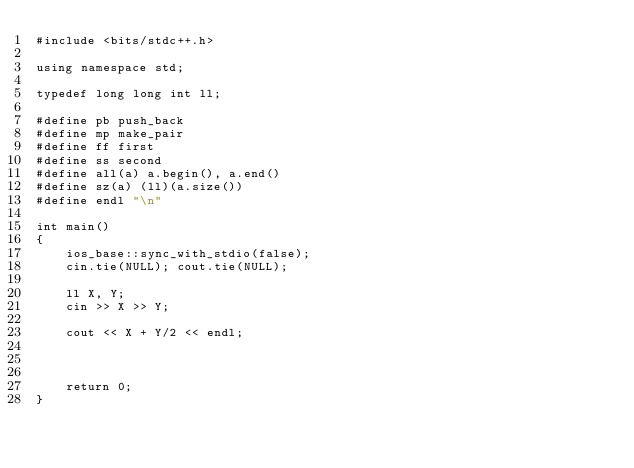<code> <loc_0><loc_0><loc_500><loc_500><_C++_>#include <bits/stdc++.h>

using namespace std;

typedef long long int ll;

#define pb push_back
#define mp make_pair
#define ff first
#define ss second
#define all(a) a.begin(), a.end()
#define sz(a) (ll)(a.size())
#define endl "\n"

int main()
{
    ios_base::sync_with_stdio(false);
    cin.tie(NULL); cout.tie(NULL);
  
  	ll X, Y;
  	cin >> X >> Y;
  
  	cout << X + Y/2 << endl;
  	
    

    return 0;
}</code> 